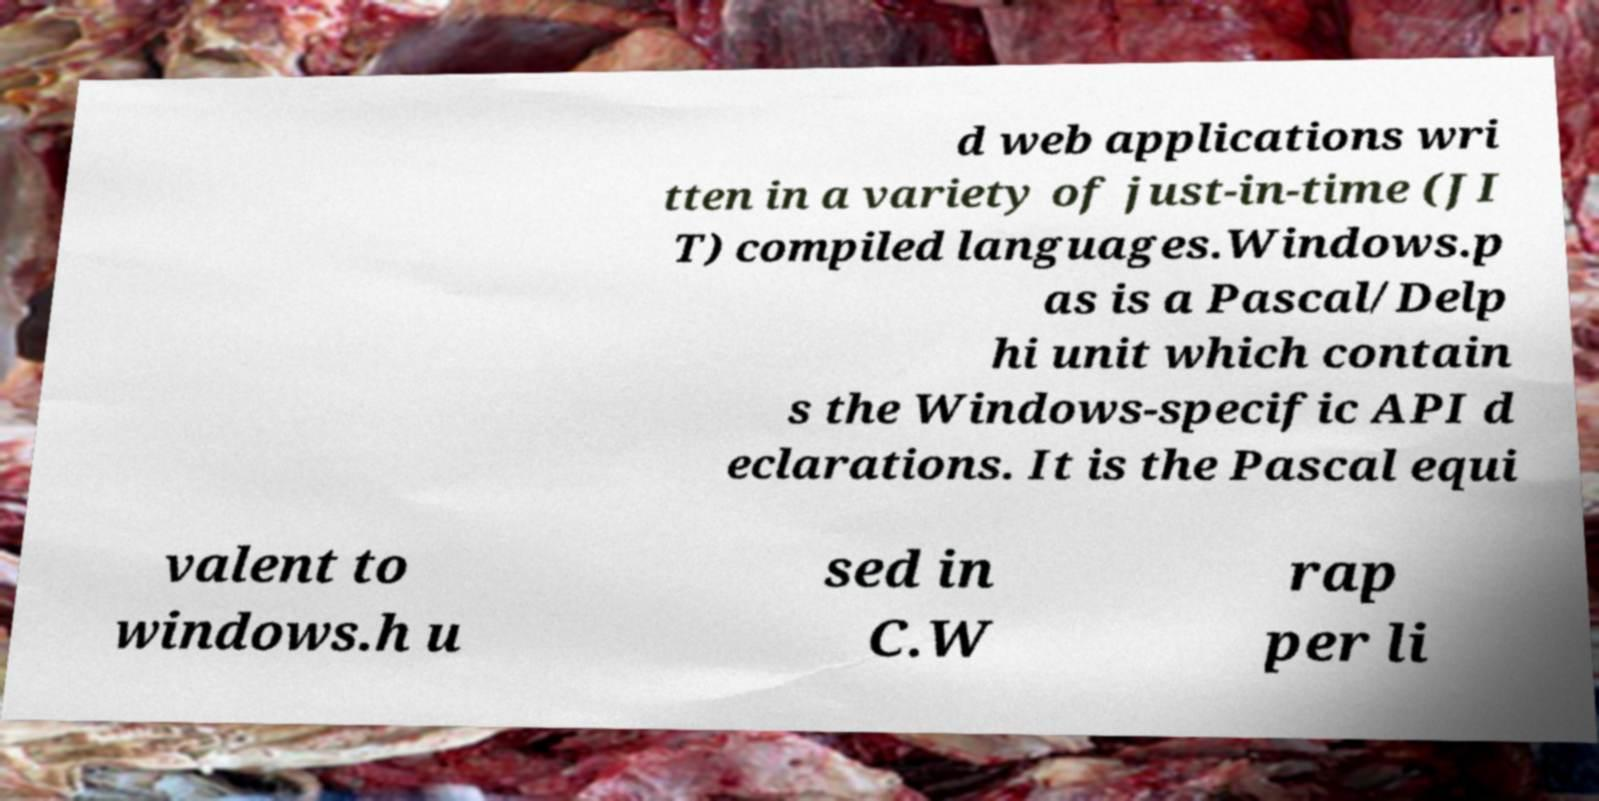Could you extract and type out the text from this image? d web applications wri tten in a variety of just-in-time (JI T) compiled languages.Windows.p as is a Pascal/Delp hi unit which contain s the Windows-specific API d eclarations. It is the Pascal equi valent to windows.h u sed in C.W rap per li 